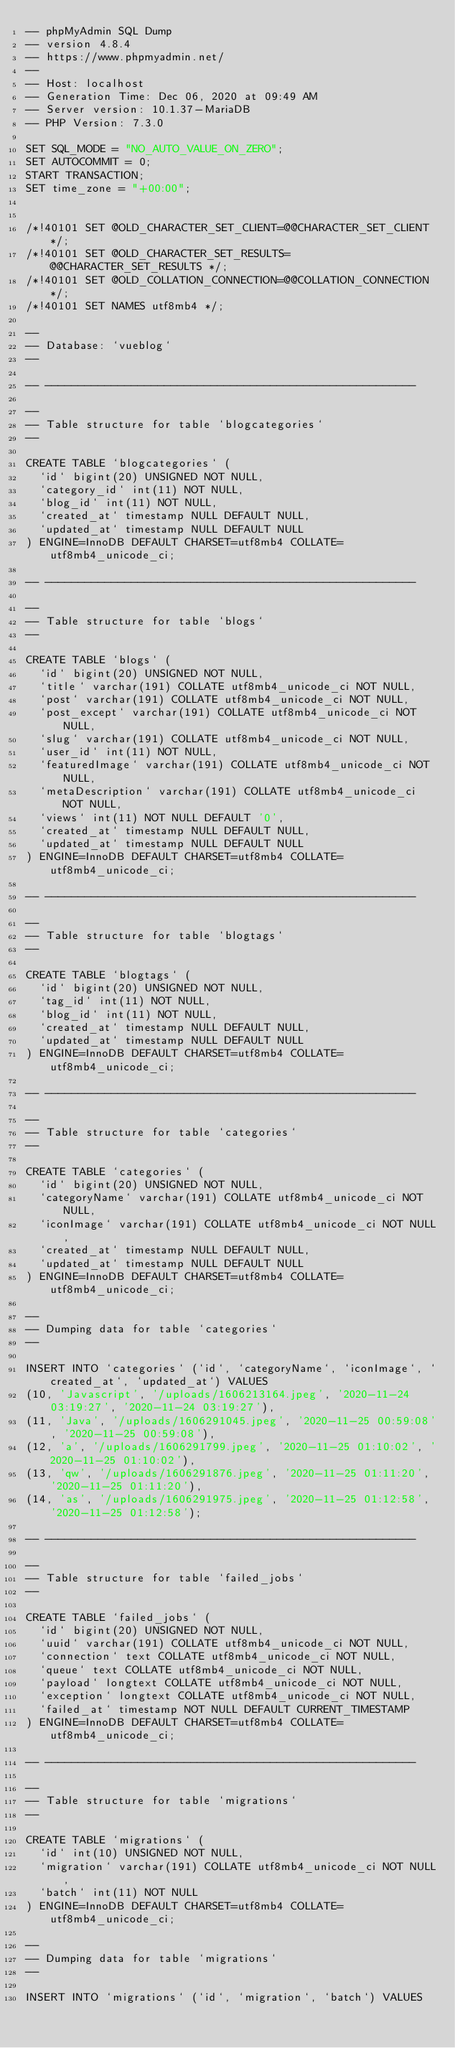Convert code to text. <code><loc_0><loc_0><loc_500><loc_500><_SQL_>-- phpMyAdmin SQL Dump
-- version 4.8.4
-- https://www.phpmyadmin.net/
--
-- Host: localhost
-- Generation Time: Dec 06, 2020 at 09:49 AM
-- Server version: 10.1.37-MariaDB
-- PHP Version: 7.3.0

SET SQL_MODE = "NO_AUTO_VALUE_ON_ZERO";
SET AUTOCOMMIT = 0;
START TRANSACTION;
SET time_zone = "+00:00";


/*!40101 SET @OLD_CHARACTER_SET_CLIENT=@@CHARACTER_SET_CLIENT */;
/*!40101 SET @OLD_CHARACTER_SET_RESULTS=@@CHARACTER_SET_RESULTS */;
/*!40101 SET @OLD_COLLATION_CONNECTION=@@COLLATION_CONNECTION */;
/*!40101 SET NAMES utf8mb4 */;

--
-- Database: `vueblog`
--

-- --------------------------------------------------------

--
-- Table structure for table `blogcategories`
--

CREATE TABLE `blogcategories` (
  `id` bigint(20) UNSIGNED NOT NULL,
  `category_id` int(11) NOT NULL,
  `blog_id` int(11) NOT NULL,
  `created_at` timestamp NULL DEFAULT NULL,
  `updated_at` timestamp NULL DEFAULT NULL
) ENGINE=InnoDB DEFAULT CHARSET=utf8mb4 COLLATE=utf8mb4_unicode_ci;

-- --------------------------------------------------------

--
-- Table structure for table `blogs`
--

CREATE TABLE `blogs` (
  `id` bigint(20) UNSIGNED NOT NULL,
  `title` varchar(191) COLLATE utf8mb4_unicode_ci NOT NULL,
  `post` varchar(191) COLLATE utf8mb4_unicode_ci NOT NULL,
  `post_except` varchar(191) COLLATE utf8mb4_unicode_ci NOT NULL,
  `slug` varchar(191) COLLATE utf8mb4_unicode_ci NOT NULL,
  `user_id` int(11) NOT NULL,
  `featuredImage` varchar(191) COLLATE utf8mb4_unicode_ci NOT NULL,
  `metaDescription` varchar(191) COLLATE utf8mb4_unicode_ci NOT NULL,
  `views` int(11) NOT NULL DEFAULT '0',
  `created_at` timestamp NULL DEFAULT NULL,
  `updated_at` timestamp NULL DEFAULT NULL
) ENGINE=InnoDB DEFAULT CHARSET=utf8mb4 COLLATE=utf8mb4_unicode_ci;

-- --------------------------------------------------------

--
-- Table structure for table `blogtags`
--

CREATE TABLE `blogtags` (
  `id` bigint(20) UNSIGNED NOT NULL,
  `tag_id` int(11) NOT NULL,
  `blog_id` int(11) NOT NULL,
  `created_at` timestamp NULL DEFAULT NULL,
  `updated_at` timestamp NULL DEFAULT NULL
) ENGINE=InnoDB DEFAULT CHARSET=utf8mb4 COLLATE=utf8mb4_unicode_ci;

-- --------------------------------------------------------

--
-- Table structure for table `categories`
--

CREATE TABLE `categories` (
  `id` bigint(20) UNSIGNED NOT NULL,
  `categoryName` varchar(191) COLLATE utf8mb4_unicode_ci NOT NULL,
  `iconImage` varchar(191) COLLATE utf8mb4_unicode_ci NOT NULL,
  `created_at` timestamp NULL DEFAULT NULL,
  `updated_at` timestamp NULL DEFAULT NULL
) ENGINE=InnoDB DEFAULT CHARSET=utf8mb4 COLLATE=utf8mb4_unicode_ci;

--
-- Dumping data for table `categories`
--

INSERT INTO `categories` (`id`, `categoryName`, `iconImage`, `created_at`, `updated_at`) VALUES
(10, 'Javascript', '/uploads/1606213164.jpeg', '2020-11-24 03:19:27', '2020-11-24 03:19:27'),
(11, 'Java', '/uploads/1606291045.jpeg', '2020-11-25 00:59:08', '2020-11-25 00:59:08'),
(12, 'a', '/uploads/1606291799.jpeg', '2020-11-25 01:10:02', '2020-11-25 01:10:02'),
(13, 'qw', '/uploads/1606291876.jpeg', '2020-11-25 01:11:20', '2020-11-25 01:11:20'),
(14, 'as', '/uploads/1606291975.jpeg', '2020-11-25 01:12:58', '2020-11-25 01:12:58');

-- --------------------------------------------------------

--
-- Table structure for table `failed_jobs`
--

CREATE TABLE `failed_jobs` (
  `id` bigint(20) UNSIGNED NOT NULL,
  `uuid` varchar(191) COLLATE utf8mb4_unicode_ci NOT NULL,
  `connection` text COLLATE utf8mb4_unicode_ci NOT NULL,
  `queue` text COLLATE utf8mb4_unicode_ci NOT NULL,
  `payload` longtext COLLATE utf8mb4_unicode_ci NOT NULL,
  `exception` longtext COLLATE utf8mb4_unicode_ci NOT NULL,
  `failed_at` timestamp NOT NULL DEFAULT CURRENT_TIMESTAMP
) ENGINE=InnoDB DEFAULT CHARSET=utf8mb4 COLLATE=utf8mb4_unicode_ci;

-- --------------------------------------------------------

--
-- Table structure for table `migrations`
--

CREATE TABLE `migrations` (
  `id` int(10) UNSIGNED NOT NULL,
  `migration` varchar(191) COLLATE utf8mb4_unicode_ci NOT NULL,
  `batch` int(11) NOT NULL
) ENGINE=InnoDB DEFAULT CHARSET=utf8mb4 COLLATE=utf8mb4_unicode_ci;

--
-- Dumping data for table `migrations`
--

INSERT INTO `migrations` (`id`, `migration`, `batch`) VALUES</code> 